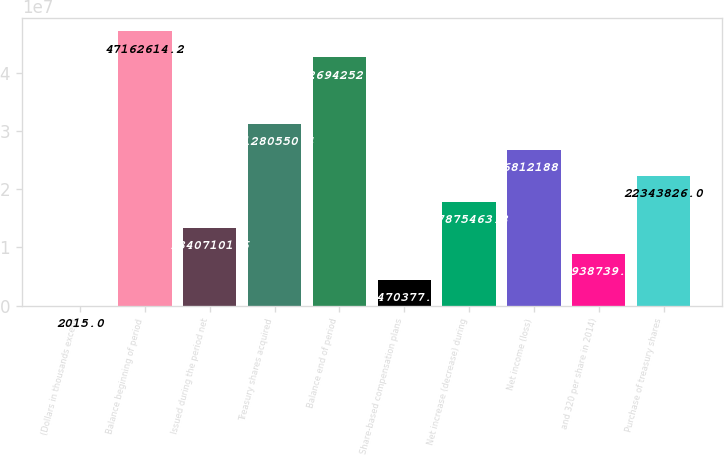Convert chart to OTSL. <chart><loc_0><loc_0><loc_500><loc_500><bar_chart><fcel>(Dollars in thousands except<fcel>Balance beginning of period<fcel>Issued during the period net<fcel>Treasury shares acquired<fcel>Balance end of period<fcel>Share-based compensation plans<fcel>Net increase (decrease) during<fcel>Net income (loss)<fcel>and 320 per share in 2014)<fcel>Purchase of treasury shares<nl><fcel>2015<fcel>4.71626e+07<fcel>1.34071e+07<fcel>3.12806e+07<fcel>4.26943e+07<fcel>4.47038e+06<fcel>1.78755e+07<fcel>2.68122e+07<fcel>8.93874e+06<fcel>2.23438e+07<nl></chart> 